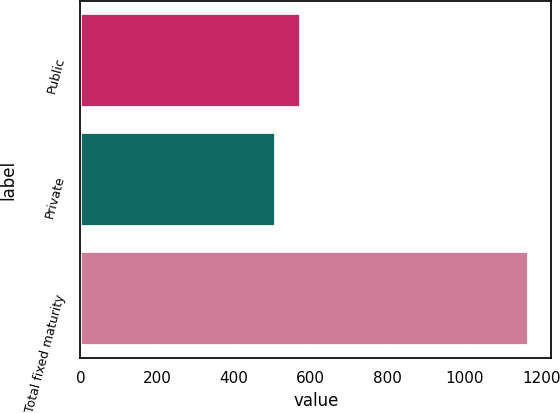Convert chart. <chart><loc_0><loc_0><loc_500><loc_500><bar_chart><fcel>Public<fcel>Private<fcel>Total fixed maturity<nl><fcel>575.73<fcel>509.9<fcel>1168.2<nl></chart> 